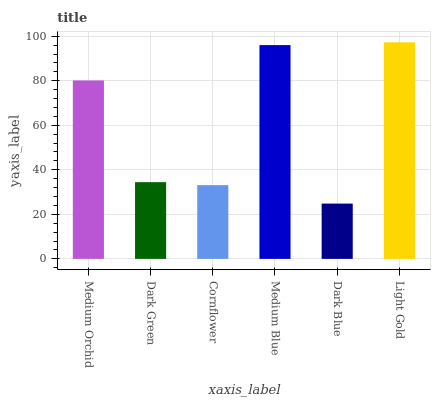Is Dark Blue the minimum?
Answer yes or no. Yes. Is Light Gold the maximum?
Answer yes or no. Yes. Is Dark Green the minimum?
Answer yes or no. No. Is Dark Green the maximum?
Answer yes or no. No. Is Medium Orchid greater than Dark Green?
Answer yes or no. Yes. Is Dark Green less than Medium Orchid?
Answer yes or no. Yes. Is Dark Green greater than Medium Orchid?
Answer yes or no. No. Is Medium Orchid less than Dark Green?
Answer yes or no. No. Is Medium Orchid the high median?
Answer yes or no. Yes. Is Dark Green the low median?
Answer yes or no. Yes. Is Cornflower the high median?
Answer yes or no. No. Is Medium Blue the low median?
Answer yes or no. No. 